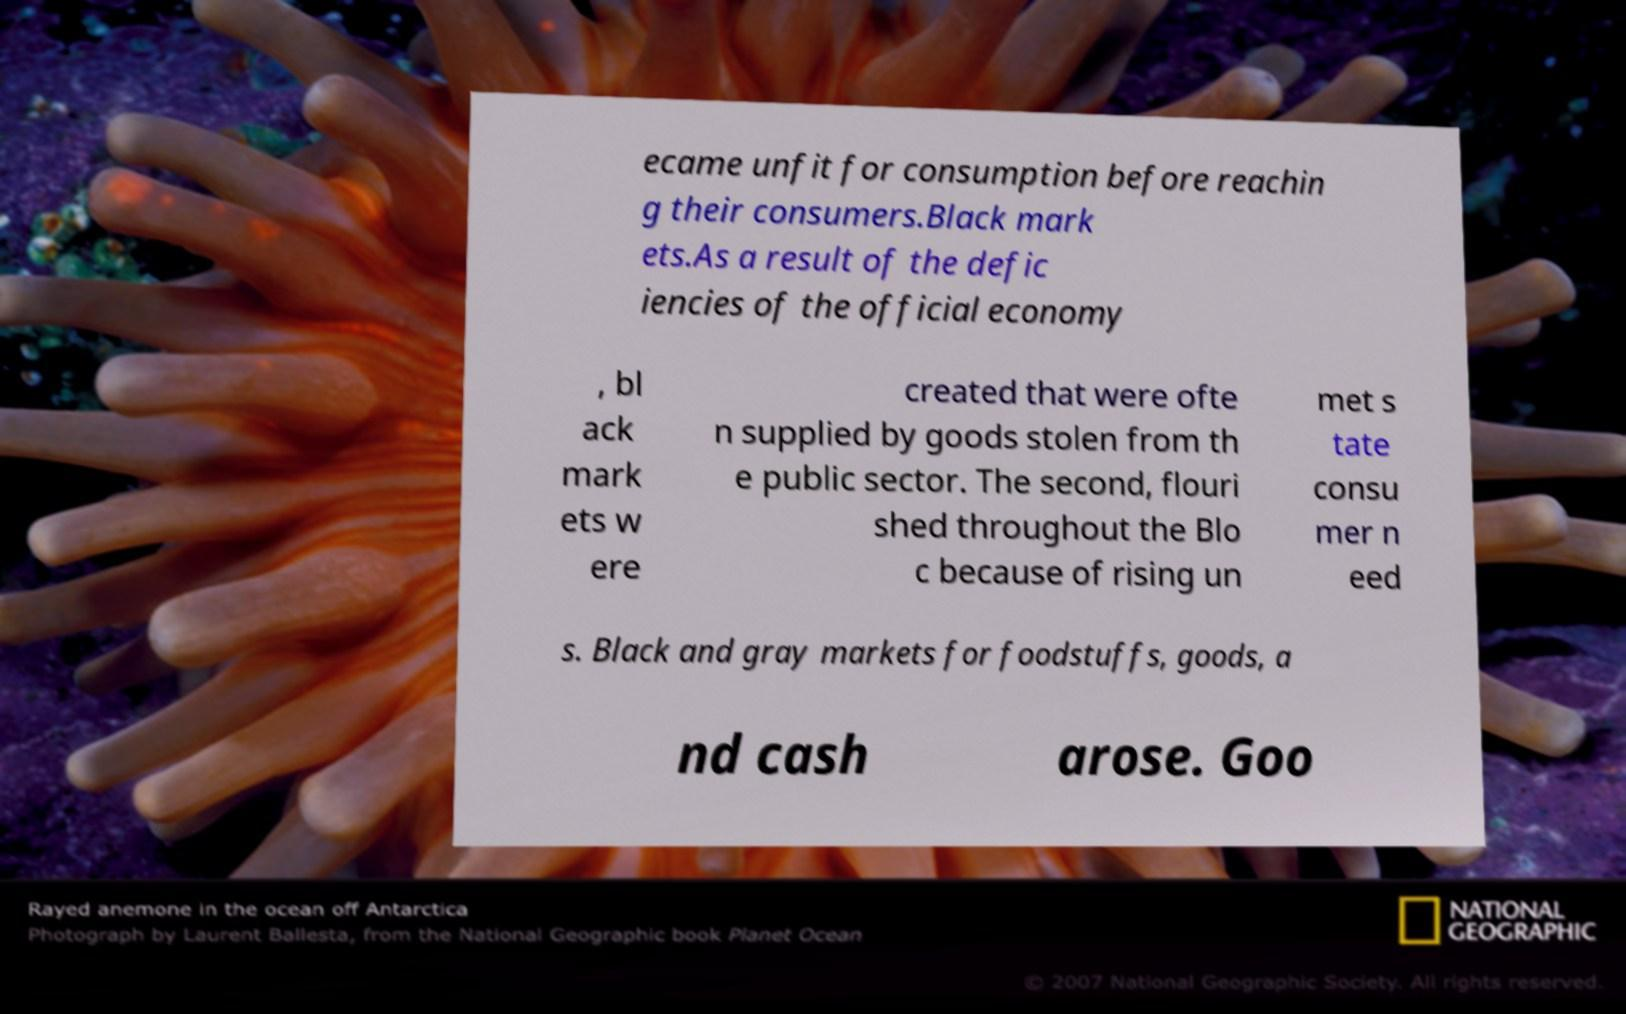For documentation purposes, I need the text within this image transcribed. Could you provide that? ecame unfit for consumption before reachin g their consumers.Black mark ets.As a result of the defic iencies of the official economy , bl ack mark ets w ere created that were ofte n supplied by goods stolen from th e public sector. The second, flouri shed throughout the Blo c because of rising un met s tate consu mer n eed s. Black and gray markets for foodstuffs, goods, a nd cash arose. Goo 